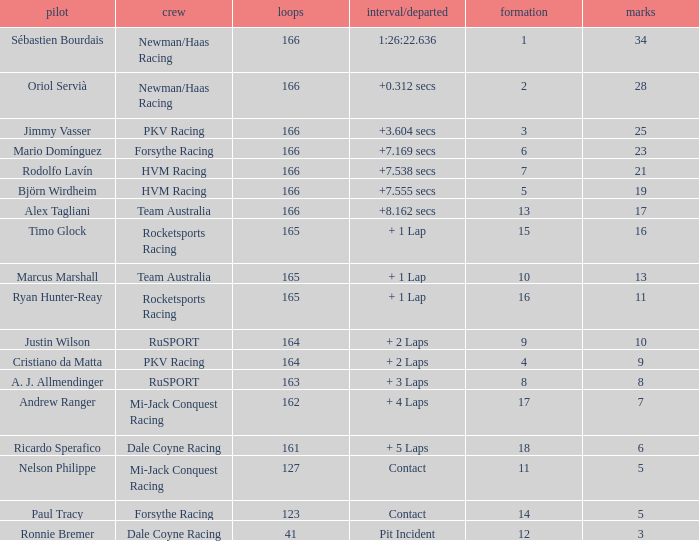What is the name of the driver with 6 points? Ricardo Sperafico. 